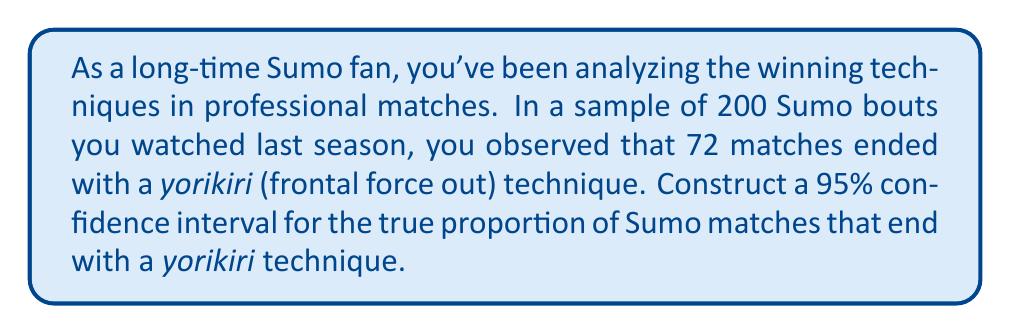Solve this math problem. Let's approach this step-by-step:

1) First, we need to identify our parameters:
   $n$ = sample size = 200
   $\hat{p}$ = sample proportion = 72/200 = 0.36
   Confidence level = 95%, so $z^*$ = 1.96

2) The formula for a confidence interval for a proportion is:

   $$\hat{p} \pm z^* \sqrt{\frac{\hat{p}(1-\hat{p})}{n}}$$

3) Let's calculate the margin of error:

   $$\text{Margin of Error} = z^* \sqrt{\frac{\hat{p}(1-\hat{p})}{n}}$$
   $$= 1.96 \sqrt{\frac{0.36(1-0.36)}{200}}$$
   $$= 1.96 \sqrt{\frac{0.2304}{200}}$$
   $$= 1.96 \sqrt{0.001152}$$
   $$= 1.96 * 0.0339 \approx 0.0665$$

4) Now we can construct the confidence interval:

   Lower bound: $0.36 - 0.0665 = 0.2935$
   Upper bound: $0.36 + 0.0665 = 0.4265$

5) Therefore, we are 95% confident that the true proportion of Sumo matches ending with a yorikiri technique is between 0.2935 and 0.4265, or approximately between 29.35% and 42.65%.
Answer: (0.2935, 0.4265) 